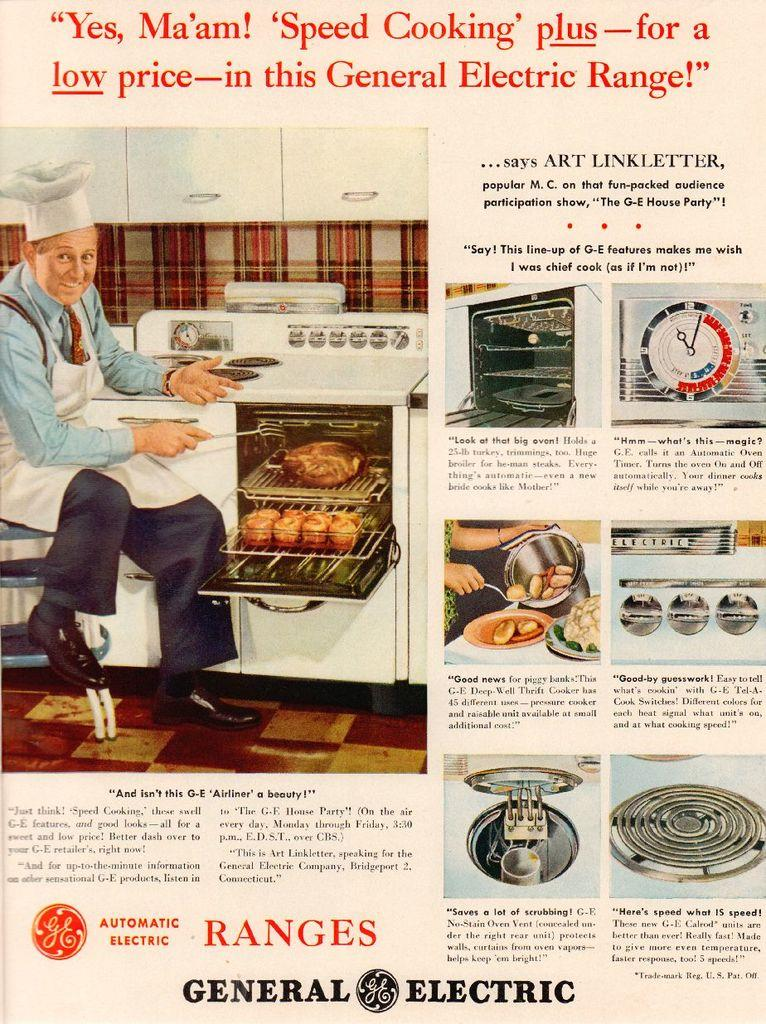Provide a one-sentence caption for the provided image. Page from an advertisement which says "General Electric" on the bottom. 